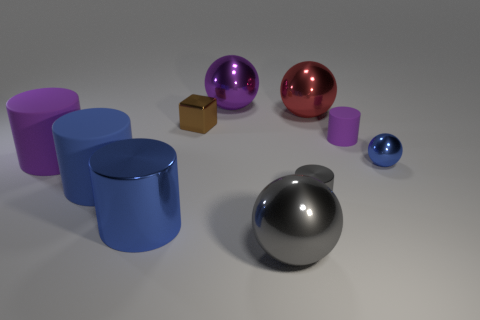Is the number of blue matte cylinders to the right of the small rubber cylinder greater than the number of big cyan metallic objects?
Your answer should be very brief. No. Is there anything else that has the same material as the cube?
Your response must be concise. Yes. There is a ball that is in front of the tiny blue metallic object; is it the same color as the matte thing that is right of the blue metallic cylinder?
Give a very brief answer. No. There is a purple object that is on the left side of the large purple ball that is behind the purple cylinder right of the large blue rubber object; what is its material?
Make the answer very short. Rubber. Are there more large purple things than red matte spheres?
Ensure brevity in your answer.  Yes. Is there any other thing that is the same color as the cube?
Keep it short and to the point. No. There is a brown block that is made of the same material as the red ball; what is its size?
Offer a very short reply. Small. What is the big purple cylinder made of?
Provide a short and direct response. Rubber. What number of balls have the same size as the gray cylinder?
Your answer should be compact. 1. What shape is the metal thing that is the same color as the big metal cylinder?
Provide a short and direct response. Sphere. 